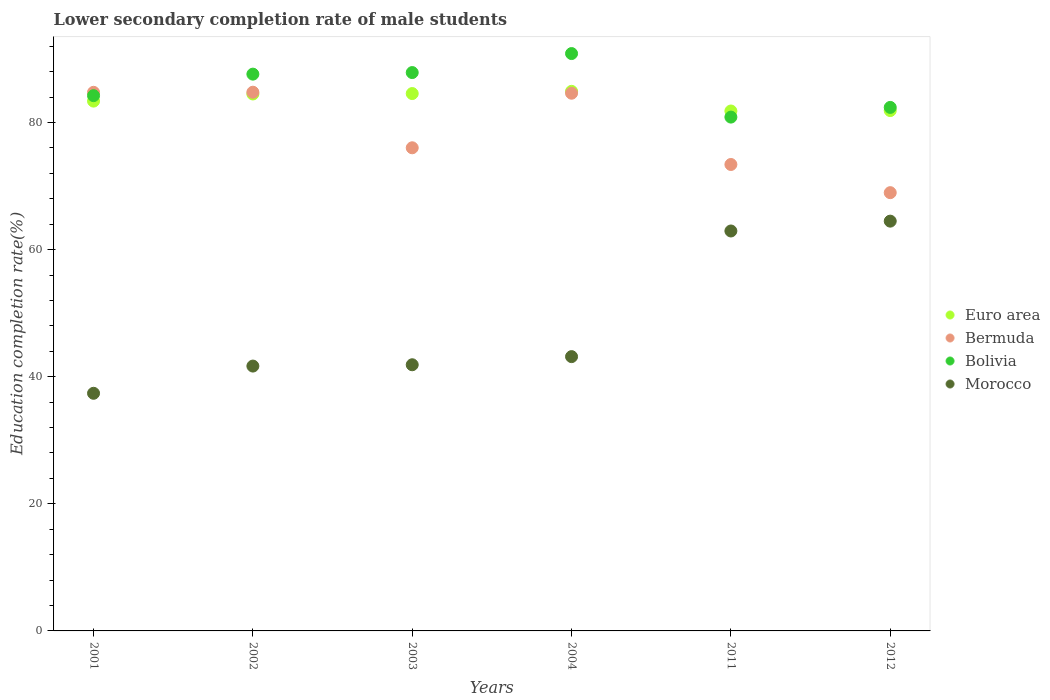What is the lower secondary completion rate of male students in Euro area in 2002?
Your answer should be very brief. 84.5. Across all years, what is the maximum lower secondary completion rate of male students in Bermuda?
Your response must be concise. 84.77. Across all years, what is the minimum lower secondary completion rate of male students in Morocco?
Offer a very short reply. 37.39. What is the total lower secondary completion rate of male students in Euro area in the graph?
Keep it short and to the point. 501.04. What is the difference between the lower secondary completion rate of male students in Euro area in 2001 and that in 2012?
Offer a terse response. 1.49. What is the difference between the lower secondary completion rate of male students in Euro area in 2004 and the lower secondary completion rate of male students in Bermuda in 2002?
Your response must be concise. 0.14. What is the average lower secondary completion rate of male students in Bolivia per year?
Make the answer very short. 85.63. In the year 2004, what is the difference between the lower secondary completion rate of male students in Morocco and lower secondary completion rate of male students in Euro area?
Provide a short and direct response. -41.74. In how many years, is the lower secondary completion rate of male students in Bermuda greater than 48 %?
Your answer should be very brief. 6. What is the ratio of the lower secondary completion rate of male students in Bermuda in 2001 to that in 2003?
Offer a very short reply. 1.11. Is the difference between the lower secondary completion rate of male students in Morocco in 2001 and 2004 greater than the difference between the lower secondary completion rate of male students in Euro area in 2001 and 2004?
Provide a succinct answer. No. What is the difference between the highest and the second highest lower secondary completion rate of male students in Bolivia?
Offer a terse response. 2.99. What is the difference between the highest and the lowest lower secondary completion rate of male students in Morocco?
Your answer should be very brief. 27.09. In how many years, is the lower secondary completion rate of male students in Bolivia greater than the average lower secondary completion rate of male students in Bolivia taken over all years?
Provide a short and direct response. 3. Is the sum of the lower secondary completion rate of male students in Euro area in 2004 and 2011 greater than the maximum lower secondary completion rate of male students in Bolivia across all years?
Your answer should be very brief. Yes. Is it the case that in every year, the sum of the lower secondary completion rate of male students in Bermuda and lower secondary completion rate of male students in Euro area  is greater than the sum of lower secondary completion rate of male students in Bolivia and lower secondary completion rate of male students in Morocco?
Ensure brevity in your answer.  No. Is it the case that in every year, the sum of the lower secondary completion rate of male students in Bolivia and lower secondary completion rate of male students in Bermuda  is greater than the lower secondary completion rate of male students in Morocco?
Make the answer very short. Yes. Does the lower secondary completion rate of male students in Bermuda monotonically increase over the years?
Keep it short and to the point. No. Is the lower secondary completion rate of male students in Morocco strictly greater than the lower secondary completion rate of male students in Bermuda over the years?
Give a very brief answer. No. Is the lower secondary completion rate of male students in Bolivia strictly less than the lower secondary completion rate of male students in Bermuda over the years?
Provide a short and direct response. No. Are the values on the major ticks of Y-axis written in scientific E-notation?
Offer a terse response. No. Does the graph contain any zero values?
Give a very brief answer. No. Does the graph contain grids?
Make the answer very short. No. How many legend labels are there?
Keep it short and to the point. 4. How are the legend labels stacked?
Your response must be concise. Vertical. What is the title of the graph?
Offer a very short reply. Lower secondary completion rate of male students. Does "Honduras" appear as one of the legend labels in the graph?
Offer a very short reply. No. What is the label or title of the X-axis?
Offer a very short reply. Years. What is the label or title of the Y-axis?
Offer a terse response. Education completion rate(%). What is the Education completion rate(%) of Euro area in 2001?
Your answer should be compact. 83.37. What is the Education completion rate(%) in Bermuda in 2001?
Provide a succinct answer. 84.76. What is the Education completion rate(%) in Bolivia in 2001?
Offer a terse response. 84.23. What is the Education completion rate(%) in Morocco in 2001?
Give a very brief answer. 37.39. What is the Education completion rate(%) in Euro area in 2002?
Make the answer very short. 84.5. What is the Education completion rate(%) of Bermuda in 2002?
Your response must be concise. 84.77. What is the Education completion rate(%) in Bolivia in 2002?
Offer a terse response. 87.62. What is the Education completion rate(%) in Morocco in 2002?
Make the answer very short. 41.68. What is the Education completion rate(%) of Euro area in 2003?
Provide a succinct answer. 84.56. What is the Education completion rate(%) of Bermuda in 2003?
Ensure brevity in your answer.  76.03. What is the Education completion rate(%) in Bolivia in 2003?
Make the answer very short. 87.86. What is the Education completion rate(%) of Morocco in 2003?
Keep it short and to the point. 41.88. What is the Education completion rate(%) of Euro area in 2004?
Make the answer very short. 84.91. What is the Education completion rate(%) of Bermuda in 2004?
Keep it short and to the point. 84.62. What is the Education completion rate(%) of Bolivia in 2004?
Offer a very short reply. 90.86. What is the Education completion rate(%) of Morocco in 2004?
Your answer should be very brief. 43.16. What is the Education completion rate(%) of Euro area in 2011?
Offer a terse response. 81.82. What is the Education completion rate(%) in Bermuda in 2011?
Provide a succinct answer. 73.4. What is the Education completion rate(%) in Bolivia in 2011?
Give a very brief answer. 80.86. What is the Education completion rate(%) in Morocco in 2011?
Your answer should be compact. 62.94. What is the Education completion rate(%) in Euro area in 2012?
Your response must be concise. 81.88. What is the Education completion rate(%) of Bermuda in 2012?
Your answer should be compact. 68.97. What is the Education completion rate(%) of Bolivia in 2012?
Your response must be concise. 82.38. What is the Education completion rate(%) in Morocco in 2012?
Offer a very short reply. 64.48. Across all years, what is the maximum Education completion rate(%) of Euro area?
Offer a terse response. 84.91. Across all years, what is the maximum Education completion rate(%) of Bermuda?
Provide a succinct answer. 84.77. Across all years, what is the maximum Education completion rate(%) in Bolivia?
Offer a terse response. 90.86. Across all years, what is the maximum Education completion rate(%) in Morocco?
Your response must be concise. 64.48. Across all years, what is the minimum Education completion rate(%) of Euro area?
Keep it short and to the point. 81.82. Across all years, what is the minimum Education completion rate(%) in Bermuda?
Your response must be concise. 68.97. Across all years, what is the minimum Education completion rate(%) in Bolivia?
Provide a succinct answer. 80.86. Across all years, what is the minimum Education completion rate(%) of Morocco?
Keep it short and to the point. 37.39. What is the total Education completion rate(%) in Euro area in the graph?
Offer a terse response. 501.04. What is the total Education completion rate(%) of Bermuda in the graph?
Make the answer very short. 472.54. What is the total Education completion rate(%) in Bolivia in the graph?
Give a very brief answer. 513.81. What is the total Education completion rate(%) in Morocco in the graph?
Offer a terse response. 291.54. What is the difference between the Education completion rate(%) in Euro area in 2001 and that in 2002?
Provide a short and direct response. -1.12. What is the difference between the Education completion rate(%) in Bermuda in 2001 and that in 2002?
Provide a short and direct response. -0.02. What is the difference between the Education completion rate(%) in Bolivia in 2001 and that in 2002?
Your answer should be compact. -3.39. What is the difference between the Education completion rate(%) of Morocco in 2001 and that in 2002?
Provide a succinct answer. -4.28. What is the difference between the Education completion rate(%) in Euro area in 2001 and that in 2003?
Give a very brief answer. -1.19. What is the difference between the Education completion rate(%) in Bermuda in 2001 and that in 2003?
Offer a terse response. 8.73. What is the difference between the Education completion rate(%) in Bolivia in 2001 and that in 2003?
Offer a terse response. -3.63. What is the difference between the Education completion rate(%) in Morocco in 2001 and that in 2003?
Give a very brief answer. -4.49. What is the difference between the Education completion rate(%) of Euro area in 2001 and that in 2004?
Give a very brief answer. -1.54. What is the difference between the Education completion rate(%) of Bermuda in 2001 and that in 2004?
Make the answer very short. 0.14. What is the difference between the Education completion rate(%) in Bolivia in 2001 and that in 2004?
Your answer should be very brief. -6.62. What is the difference between the Education completion rate(%) in Morocco in 2001 and that in 2004?
Provide a succinct answer. -5.77. What is the difference between the Education completion rate(%) of Euro area in 2001 and that in 2011?
Provide a short and direct response. 1.56. What is the difference between the Education completion rate(%) in Bermuda in 2001 and that in 2011?
Give a very brief answer. 11.36. What is the difference between the Education completion rate(%) of Bolivia in 2001 and that in 2011?
Provide a succinct answer. 3.37. What is the difference between the Education completion rate(%) in Morocco in 2001 and that in 2011?
Ensure brevity in your answer.  -25.54. What is the difference between the Education completion rate(%) in Euro area in 2001 and that in 2012?
Provide a short and direct response. 1.49. What is the difference between the Education completion rate(%) of Bermuda in 2001 and that in 2012?
Provide a succinct answer. 15.79. What is the difference between the Education completion rate(%) of Bolivia in 2001 and that in 2012?
Offer a very short reply. 1.85. What is the difference between the Education completion rate(%) in Morocco in 2001 and that in 2012?
Make the answer very short. -27.09. What is the difference between the Education completion rate(%) of Euro area in 2002 and that in 2003?
Provide a short and direct response. -0.07. What is the difference between the Education completion rate(%) in Bermuda in 2002 and that in 2003?
Offer a very short reply. 8.75. What is the difference between the Education completion rate(%) in Bolivia in 2002 and that in 2003?
Offer a terse response. -0.25. What is the difference between the Education completion rate(%) in Morocco in 2002 and that in 2003?
Your response must be concise. -0.21. What is the difference between the Education completion rate(%) in Euro area in 2002 and that in 2004?
Make the answer very short. -0.41. What is the difference between the Education completion rate(%) of Bermuda in 2002 and that in 2004?
Ensure brevity in your answer.  0.16. What is the difference between the Education completion rate(%) in Bolivia in 2002 and that in 2004?
Your response must be concise. -3.24. What is the difference between the Education completion rate(%) in Morocco in 2002 and that in 2004?
Provide a short and direct response. -1.49. What is the difference between the Education completion rate(%) in Euro area in 2002 and that in 2011?
Provide a succinct answer. 2.68. What is the difference between the Education completion rate(%) in Bermuda in 2002 and that in 2011?
Provide a short and direct response. 11.37. What is the difference between the Education completion rate(%) of Bolivia in 2002 and that in 2011?
Keep it short and to the point. 6.76. What is the difference between the Education completion rate(%) of Morocco in 2002 and that in 2011?
Your answer should be compact. -21.26. What is the difference between the Education completion rate(%) of Euro area in 2002 and that in 2012?
Make the answer very short. 2.61. What is the difference between the Education completion rate(%) of Bermuda in 2002 and that in 2012?
Give a very brief answer. 15.81. What is the difference between the Education completion rate(%) in Bolivia in 2002 and that in 2012?
Make the answer very short. 5.24. What is the difference between the Education completion rate(%) of Morocco in 2002 and that in 2012?
Keep it short and to the point. -22.81. What is the difference between the Education completion rate(%) in Euro area in 2003 and that in 2004?
Give a very brief answer. -0.35. What is the difference between the Education completion rate(%) in Bermuda in 2003 and that in 2004?
Ensure brevity in your answer.  -8.59. What is the difference between the Education completion rate(%) in Bolivia in 2003 and that in 2004?
Make the answer very short. -2.99. What is the difference between the Education completion rate(%) in Morocco in 2003 and that in 2004?
Your answer should be compact. -1.28. What is the difference between the Education completion rate(%) in Euro area in 2003 and that in 2011?
Your answer should be compact. 2.75. What is the difference between the Education completion rate(%) in Bermuda in 2003 and that in 2011?
Offer a very short reply. 2.63. What is the difference between the Education completion rate(%) of Bolivia in 2003 and that in 2011?
Provide a succinct answer. 7.01. What is the difference between the Education completion rate(%) of Morocco in 2003 and that in 2011?
Offer a very short reply. -21.05. What is the difference between the Education completion rate(%) in Euro area in 2003 and that in 2012?
Offer a terse response. 2.68. What is the difference between the Education completion rate(%) in Bermuda in 2003 and that in 2012?
Make the answer very short. 7.06. What is the difference between the Education completion rate(%) of Bolivia in 2003 and that in 2012?
Give a very brief answer. 5.48. What is the difference between the Education completion rate(%) of Morocco in 2003 and that in 2012?
Ensure brevity in your answer.  -22.6. What is the difference between the Education completion rate(%) of Euro area in 2004 and that in 2011?
Offer a very short reply. 3.09. What is the difference between the Education completion rate(%) in Bermuda in 2004 and that in 2011?
Your answer should be compact. 11.22. What is the difference between the Education completion rate(%) of Bolivia in 2004 and that in 2011?
Your response must be concise. 10. What is the difference between the Education completion rate(%) in Morocco in 2004 and that in 2011?
Make the answer very short. -19.77. What is the difference between the Education completion rate(%) in Euro area in 2004 and that in 2012?
Ensure brevity in your answer.  3.02. What is the difference between the Education completion rate(%) in Bermuda in 2004 and that in 2012?
Provide a short and direct response. 15.65. What is the difference between the Education completion rate(%) in Bolivia in 2004 and that in 2012?
Ensure brevity in your answer.  8.47. What is the difference between the Education completion rate(%) of Morocco in 2004 and that in 2012?
Keep it short and to the point. -21.32. What is the difference between the Education completion rate(%) of Euro area in 2011 and that in 2012?
Ensure brevity in your answer.  -0.07. What is the difference between the Education completion rate(%) in Bermuda in 2011 and that in 2012?
Keep it short and to the point. 4.43. What is the difference between the Education completion rate(%) in Bolivia in 2011 and that in 2012?
Provide a short and direct response. -1.52. What is the difference between the Education completion rate(%) of Morocco in 2011 and that in 2012?
Provide a succinct answer. -1.55. What is the difference between the Education completion rate(%) of Euro area in 2001 and the Education completion rate(%) of Bermuda in 2002?
Your answer should be very brief. -1.4. What is the difference between the Education completion rate(%) in Euro area in 2001 and the Education completion rate(%) in Bolivia in 2002?
Make the answer very short. -4.24. What is the difference between the Education completion rate(%) in Euro area in 2001 and the Education completion rate(%) in Morocco in 2002?
Offer a very short reply. 41.7. What is the difference between the Education completion rate(%) in Bermuda in 2001 and the Education completion rate(%) in Bolivia in 2002?
Offer a very short reply. -2.86. What is the difference between the Education completion rate(%) of Bermuda in 2001 and the Education completion rate(%) of Morocco in 2002?
Your answer should be very brief. 43.08. What is the difference between the Education completion rate(%) of Bolivia in 2001 and the Education completion rate(%) of Morocco in 2002?
Provide a succinct answer. 42.55. What is the difference between the Education completion rate(%) of Euro area in 2001 and the Education completion rate(%) of Bermuda in 2003?
Ensure brevity in your answer.  7.35. What is the difference between the Education completion rate(%) of Euro area in 2001 and the Education completion rate(%) of Bolivia in 2003?
Provide a short and direct response. -4.49. What is the difference between the Education completion rate(%) in Euro area in 2001 and the Education completion rate(%) in Morocco in 2003?
Keep it short and to the point. 41.49. What is the difference between the Education completion rate(%) in Bermuda in 2001 and the Education completion rate(%) in Bolivia in 2003?
Your answer should be very brief. -3.11. What is the difference between the Education completion rate(%) of Bermuda in 2001 and the Education completion rate(%) of Morocco in 2003?
Offer a terse response. 42.87. What is the difference between the Education completion rate(%) of Bolivia in 2001 and the Education completion rate(%) of Morocco in 2003?
Provide a succinct answer. 42.35. What is the difference between the Education completion rate(%) in Euro area in 2001 and the Education completion rate(%) in Bermuda in 2004?
Make the answer very short. -1.24. What is the difference between the Education completion rate(%) of Euro area in 2001 and the Education completion rate(%) of Bolivia in 2004?
Offer a very short reply. -7.48. What is the difference between the Education completion rate(%) of Euro area in 2001 and the Education completion rate(%) of Morocco in 2004?
Provide a succinct answer. 40.21. What is the difference between the Education completion rate(%) of Bermuda in 2001 and the Education completion rate(%) of Bolivia in 2004?
Offer a terse response. -6.1. What is the difference between the Education completion rate(%) of Bermuda in 2001 and the Education completion rate(%) of Morocco in 2004?
Ensure brevity in your answer.  41.59. What is the difference between the Education completion rate(%) in Bolivia in 2001 and the Education completion rate(%) in Morocco in 2004?
Provide a succinct answer. 41.07. What is the difference between the Education completion rate(%) in Euro area in 2001 and the Education completion rate(%) in Bermuda in 2011?
Ensure brevity in your answer.  9.97. What is the difference between the Education completion rate(%) in Euro area in 2001 and the Education completion rate(%) in Bolivia in 2011?
Your response must be concise. 2.52. What is the difference between the Education completion rate(%) in Euro area in 2001 and the Education completion rate(%) in Morocco in 2011?
Give a very brief answer. 20.44. What is the difference between the Education completion rate(%) in Bermuda in 2001 and the Education completion rate(%) in Bolivia in 2011?
Your response must be concise. 3.9. What is the difference between the Education completion rate(%) in Bermuda in 2001 and the Education completion rate(%) in Morocco in 2011?
Offer a very short reply. 21.82. What is the difference between the Education completion rate(%) of Bolivia in 2001 and the Education completion rate(%) of Morocco in 2011?
Provide a succinct answer. 21.3. What is the difference between the Education completion rate(%) in Euro area in 2001 and the Education completion rate(%) in Bermuda in 2012?
Provide a short and direct response. 14.41. What is the difference between the Education completion rate(%) of Euro area in 2001 and the Education completion rate(%) of Bolivia in 2012?
Your response must be concise. 0.99. What is the difference between the Education completion rate(%) in Euro area in 2001 and the Education completion rate(%) in Morocco in 2012?
Give a very brief answer. 18.89. What is the difference between the Education completion rate(%) of Bermuda in 2001 and the Education completion rate(%) of Bolivia in 2012?
Your answer should be compact. 2.38. What is the difference between the Education completion rate(%) of Bermuda in 2001 and the Education completion rate(%) of Morocco in 2012?
Offer a very short reply. 20.27. What is the difference between the Education completion rate(%) in Bolivia in 2001 and the Education completion rate(%) in Morocco in 2012?
Provide a succinct answer. 19.75. What is the difference between the Education completion rate(%) in Euro area in 2002 and the Education completion rate(%) in Bermuda in 2003?
Your response must be concise. 8.47. What is the difference between the Education completion rate(%) of Euro area in 2002 and the Education completion rate(%) of Bolivia in 2003?
Your answer should be compact. -3.37. What is the difference between the Education completion rate(%) of Euro area in 2002 and the Education completion rate(%) of Morocco in 2003?
Your response must be concise. 42.61. What is the difference between the Education completion rate(%) in Bermuda in 2002 and the Education completion rate(%) in Bolivia in 2003?
Your answer should be very brief. -3.09. What is the difference between the Education completion rate(%) in Bermuda in 2002 and the Education completion rate(%) in Morocco in 2003?
Your answer should be compact. 42.89. What is the difference between the Education completion rate(%) in Bolivia in 2002 and the Education completion rate(%) in Morocco in 2003?
Give a very brief answer. 45.73. What is the difference between the Education completion rate(%) in Euro area in 2002 and the Education completion rate(%) in Bermuda in 2004?
Offer a very short reply. -0.12. What is the difference between the Education completion rate(%) in Euro area in 2002 and the Education completion rate(%) in Bolivia in 2004?
Provide a short and direct response. -6.36. What is the difference between the Education completion rate(%) in Euro area in 2002 and the Education completion rate(%) in Morocco in 2004?
Your answer should be very brief. 41.33. What is the difference between the Education completion rate(%) in Bermuda in 2002 and the Education completion rate(%) in Bolivia in 2004?
Your response must be concise. -6.08. What is the difference between the Education completion rate(%) in Bermuda in 2002 and the Education completion rate(%) in Morocco in 2004?
Offer a terse response. 41.61. What is the difference between the Education completion rate(%) in Bolivia in 2002 and the Education completion rate(%) in Morocco in 2004?
Provide a short and direct response. 44.45. What is the difference between the Education completion rate(%) in Euro area in 2002 and the Education completion rate(%) in Bermuda in 2011?
Keep it short and to the point. 11.1. What is the difference between the Education completion rate(%) of Euro area in 2002 and the Education completion rate(%) of Bolivia in 2011?
Make the answer very short. 3.64. What is the difference between the Education completion rate(%) in Euro area in 2002 and the Education completion rate(%) in Morocco in 2011?
Provide a short and direct response. 21.56. What is the difference between the Education completion rate(%) in Bermuda in 2002 and the Education completion rate(%) in Bolivia in 2011?
Give a very brief answer. 3.92. What is the difference between the Education completion rate(%) in Bermuda in 2002 and the Education completion rate(%) in Morocco in 2011?
Your answer should be very brief. 21.84. What is the difference between the Education completion rate(%) of Bolivia in 2002 and the Education completion rate(%) of Morocco in 2011?
Provide a short and direct response. 24.68. What is the difference between the Education completion rate(%) in Euro area in 2002 and the Education completion rate(%) in Bermuda in 2012?
Make the answer very short. 15.53. What is the difference between the Education completion rate(%) in Euro area in 2002 and the Education completion rate(%) in Bolivia in 2012?
Make the answer very short. 2.11. What is the difference between the Education completion rate(%) in Euro area in 2002 and the Education completion rate(%) in Morocco in 2012?
Your answer should be compact. 20.01. What is the difference between the Education completion rate(%) in Bermuda in 2002 and the Education completion rate(%) in Bolivia in 2012?
Your response must be concise. 2.39. What is the difference between the Education completion rate(%) in Bermuda in 2002 and the Education completion rate(%) in Morocco in 2012?
Ensure brevity in your answer.  20.29. What is the difference between the Education completion rate(%) of Bolivia in 2002 and the Education completion rate(%) of Morocco in 2012?
Ensure brevity in your answer.  23.13. What is the difference between the Education completion rate(%) of Euro area in 2003 and the Education completion rate(%) of Bermuda in 2004?
Your response must be concise. -0.05. What is the difference between the Education completion rate(%) in Euro area in 2003 and the Education completion rate(%) in Bolivia in 2004?
Make the answer very short. -6.29. What is the difference between the Education completion rate(%) of Euro area in 2003 and the Education completion rate(%) of Morocco in 2004?
Offer a terse response. 41.4. What is the difference between the Education completion rate(%) in Bermuda in 2003 and the Education completion rate(%) in Bolivia in 2004?
Provide a short and direct response. -14.83. What is the difference between the Education completion rate(%) in Bermuda in 2003 and the Education completion rate(%) in Morocco in 2004?
Give a very brief answer. 32.86. What is the difference between the Education completion rate(%) of Bolivia in 2003 and the Education completion rate(%) of Morocco in 2004?
Keep it short and to the point. 44.7. What is the difference between the Education completion rate(%) in Euro area in 2003 and the Education completion rate(%) in Bermuda in 2011?
Offer a terse response. 11.16. What is the difference between the Education completion rate(%) of Euro area in 2003 and the Education completion rate(%) of Bolivia in 2011?
Make the answer very short. 3.71. What is the difference between the Education completion rate(%) in Euro area in 2003 and the Education completion rate(%) in Morocco in 2011?
Provide a succinct answer. 21.63. What is the difference between the Education completion rate(%) of Bermuda in 2003 and the Education completion rate(%) of Bolivia in 2011?
Offer a very short reply. -4.83. What is the difference between the Education completion rate(%) in Bermuda in 2003 and the Education completion rate(%) in Morocco in 2011?
Give a very brief answer. 13.09. What is the difference between the Education completion rate(%) of Bolivia in 2003 and the Education completion rate(%) of Morocco in 2011?
Offer a very short reply. 24.93. What is the difference between the Education completion rate(%) in Euro area in 2003 and the Education completion rate(%) in Bermuda in 2012?
Ensure brevity in your answer.  15.6. What is the difference between the Education completion rate(%) of Euro area in 2003 and the Education completion rate(%) of Bolivia in 2012?
Offer a terse response. 2.18. What is the difference between the Education completion rate(%) of Euro area in 2003 and the Education completion rate(%) of Morocco in 2012?
Your response must be concise. 20.08. What is the difference between the Education completion rate(%) in Bermuda in 2003 and the Education completion rate(%) in Bolivia in 2012?
Keep it short and to the point. -6.35. What is the difference between the Education completion rate(%) of Bermuda in 2003 and the Education completion rate(%) of Morocco in 2012?
Offer a very short reply. 11.54. What is the difference between the Education completion rate(%) in Bolivia in 2003 and the Education completion rate(%) in Morocco in 2012?
Offer a terse response. 23.38. What is the difference between the Education completion rate(%) of Euro area in 2004 and the Education completion rate(%) of Bermuda in 2011?
Provide a succinct answer. 11.51. What is the difference between the Education completion rate(%) in Euro area in 2004 and the Education completion rate(%) in Bolivia in 2011?
Offer a very short reply. 4.05. What is the difference between the Education completion rate(%) of Euro area in 2004 and the Education completion rate(%) of Morocco in 2011?
Offer a very short reply. 21.97. What is the difference between the Education completion rate(%) in Bermuda in 2004 and the Education completion rate(%) in Bolivia in 2011?
Your response must be concise. 3.76. What is the difference between the Education completion rate(%) of Bermuda in 2004 and the Education completion rate(%) of Morocco in 2011?
Give a very brief answer. 21.68. What is the difference between the Education completion rate(%) in Bolivia in 2004 and the Education completion rate(%) in Morocco in 2011?
Make the answer very short. 27.92. What is the difference between the Education completion rate(%) of Euro area in 2004 and the Education completion rate(%) of Bermuda in 2012?
Make the answer very short. 15.94. What is the difference between the Education completion rate(%) of Euro area in 2004 and the Education completion rate(%) of Bolivia in 2012?
Your response must be concise. 2.53. What is the difference between the Education completion rate(%) in Euro area in 2004 and the Education completion rate(%) in Morocco in 2012?
Your response must be concise. 20.42. What is the difference between the Education completion rate(%) of Bermuda in 2004 and the Education completion rate(%) of Bolivia in 2012?
Keep it short and to the point. 2.23. What is the difference between the Education completion rate(%) in Bermuda in 2004 and the Education completion rate(%) in Morocco in 2012?
Offer a very short reply. 20.13. What is the difference between the Education completion rate(%) of Bolivia in 2004 and the Education completion rate(%) of Morocco in 2012?
Your answer should be very brief. 26.37. What is the difference between the Education completion rate(%) in Euro area in 2011 and the Education completion rate(%) in Bermuda in 2012?
Your response must be concise. 12.85. What is the difference between the Education completion rate(%) of Euro area in 2011 and the Education completion rate(%) of Bolivia in 2012?
Offer a terse response. -0.56. What is the difference between the Education completion rate(%) in Euro area in 2011 and the Education completion rate(%) in Morocco in 2012?
Give a very brief answer. 17.33. What is the difference between the Education completion rate(%) in Bermuda in 2011 and the Education completion rate(%) in Bolivia in 2012?
Offer a very short reply. -8.98. What is the difference between the Education completion rate(%) of Bermuda in 2011 and the Education completion rate(%) of Morocco in 2012?
Keep it short and to the point. 8.91. What is the difference between the Education completion rate(%) of Bolivia in 2011 and the Education completion rate(%) of Morocco in 2012?
Your response must be concise. 16.37. What is the average Education completion rate(%) in Euro area per year?
Your answer should be compact. 83.51. What is the average Education completion rate(%) in Bermuda per year?
Ensure brevity in your answer.  78.76. What is the average Education completion rate(%) of Bolivia per year?
Your response must be concise. 85.63. What is the average Education completion rate(%) in Morocco per year?
Offer a very short reply. 48.59. In the year 2001, what is the difference between the Education completion rate(%) in Euro area and Education completion rate(%) in Bermuda?
Offer a very short reply. -1.39. In the year 2001, what is the difference between the Education completion rate(%) of Euro area and Education completion rate(%) of Bolivia?
Give a very brief answer. -0.86. In the year 2001, what is the difference between the Education completion rate(%) of Euro area and Education completion rate(%) of Morocco?
Provide a succinct answer. 45.98. In the year 2001, what is the difference between the Education completion rate(%) of Bermuda and Education completion rate(%) of Bolivia?
Give a very brief answer. 0.53. In the year 2001, what is the difference between the Education completion rate(%) of Bermuda and Education completion rate(%) of Morocco?
Provide a succinct answer. 47.36. In the year 2001, what is the difference between the Education completion rate(%) of Bolivia and Education completion rate(%) of Morocco?
Ensure brevity in your answer.  46.84. In the year 2002, what is the difference between the Education completion rate(%) in Euro area and Education completion rate(%) in Bermuda?
Your answer should be compact. -0.28. In the year 2002, what is the difference between the Education completion rate(%) of Euro area and Education completion rate(%) of Bolivia?
Make the answer very short. -3.12. In the year 2002, what is the difference between the Education completion rate(%) in Euro area and Education completion rate(%) in Morocco?
Ensure brevity in your answer.  42.82. In the year 2002, what is the difference between the Education completion rate(%) in Bermuda and Education completion rate(%) in Bolivia?
Keep it short and to the point. -2.84. In the year 2002, what is the difference between the Education completion rate(%) of Bermuda and Education completion rate(%) of Morocco?
Your answer should be compact. 43.1. In the year 2002, what is the difference between the Education completion rate(%) in Bolivia and Education completion rate(%) in Morocco?
Provide a short and direct response. 45.94. In the year 2003, what is the difference between the Education completion rate(%) of Euro area and Education completion rate(%) of Bermuda?
Give a very brief answer. 8.53. In the year 2003, what is the difference between the Education completion rate(%) in Euro area and Education completion rate(%) in Bolivia?
Give a very brief answer. -3.3. In the year 2003, what is the difference between the Education completion rate(%) in Euro area and Education completion rate(%) in Morocco?
Your answer should be very brief. 42.68. In the year 2003, what is the difference between the Education completion rate(%) in Bermuda and Education completion rate(%) in Bolivia?
Keep it short and to the point. -11.84. In the year 2003, what is the difference between the Education completion rate(%) of Bermuda and Education completion rate(%) of Morocco?
Your answer should be compact. 34.14. In the year 2003, what is the difference between the Education completion rate(%) in Bolivia and Education completion rate(%) in Morocco?
Give a very brief answer. 45.98. In the year 2004, what is the difference between the Education completion rate(%) of Euro area and Education completion rate(%) of Bermuda?
Provide a succinct answer. 0.29. In the year 2004, what is the difference between the Education completion rate(%) in Euro area and Education completion rate(%) in Bolivia?
Ensure brevity in your answer.  -5.95. In the year 2004, what is the difference between the Education completion rate(%) of Euro area and Education completion rate(%) of Morocco?
Offer a very short reply. 41.74. In the year 2004, what is the difference between the Education completion rate(%) in Bermuda and Education completion rate(%) in Bolivia?
Your answer should be compact. -6.24. In the year 2004, what is the difference between the Education completion rate(%) of Bermuda and Education completion rate(%) of Morocco?
Offer a very short reply. 41.45. In the year 2004, what is the difference between the Education completion rate(%) of Bolivia and Education completion rate(%) of Morocco?
Provide a short and direct response. 47.69. In the year 2011, what is the difference between the Education completion rate(%) of Euro area and Education completion rate(%) of Bermuda?
Ensure brevity in your answer.  8.42. In the year 2011, what is the difference between the Education completion rate(%) in Euro area and Education completion rate(%) in Bolivia?
Offer a very short reply. 0.96. In the year 2011, what is the difference between the Education completion rate(%) in Euro area and Education completion rate(%) in Morocco?
Your answer should be compact. 18.88. In the year 2011, what is the difference between the Education completion rate(%) in Bermuda and Education completion rate(%) in Bolivia?
Offer a terse response. -7.46. In the year 2011, what is the difference between the Education completion rate(%) in Bermuda and Education completion rate(%) in Morocco?
Your answer should be compact. 10.46. In the year 2011, what is the difference between the Education completion rate(%) in Bolivia and Education completion rate(%) in Morocco?
Provide a succinct answer. 17.92. In the year 2012, what is the difference between the Education completion rate(%) in Euro area and Education completion rate(%) in Bermuda?
Provide a succinct answer. 12.92. In the year 2012, what is the difference between the Education completion rate(%) in Euro area and Education completion rate(%) in Bolivia?
Ensure brevity in your answer.  -0.5. In the year 2012, what is the difference between the Education completion rate(%) in Euro area and Education completion rate(%) in Morocco?
Give a very brief answer. 17.4. In the year 2012, what is the difference between the Education completion rate(%) of Bermuda and Education completion rate(%) of Bolivia?
Your answer should be very brief. -13.42. In the year 2012, what is the difference between the Education completion rate(%) of Bermuda and Education completion rate(%) of Morocco?
Your answer should be compact. 4.48. In the year 2012, what is the difference between the Education completion rate(%) in Bolivia and Education completion rate(%) in Morocco?
Keep it short and to the point. 17.9. What is the ratio of the Education completion rate(%) in Euro area in 2001 to that in 2002?
Offer a very short reply. 0.99. What is the ratio of the Education completion rate(%) of Bermuda in 2001 to that in 2002?
Provide a succinct answer. 1. What is the ratio of the Education completion rate(%) in Bolivia in 2001 to that in 2002?
Your answer should be very brief. 0.96. What is the ratio of the Education completion rate(%) of Morocco in 2001 to that in 2002?
Offer a very short reply. 0.9. What is the ratio of the Education completion rate(%) of Euro area in 2001 to that in 2003?
Provide a short and direct response. 0.99. What is the ratio of the Education completion rate(%) of Bermuda in 2001 to that in 2003?
Make the answer very short. 1.11. What is the ratio of the Education completion rate(%) in Bolivia in 2001 to that in 2003?
Your answer should be very brief. 0.96. What is the ratio of the Education completion rate(%) in Morocco in 2001 to that in 2003?
Make the answer very short. 0.89. What is the ratio of the Education completion rate(%) of Euro area in 2001 to that in 2004?
Keep it short and to the point. 0.98. What is the ratio of the Education completion rate(%) in Bermuda in 2001 to that in 2004?
Offer a very short reply. 1. What is the ratio of the Education completion rate(%) in Bolivia in 2001 to that in 2004?
Your answer should be compact. 0.93. What is the ratio of the Education completion rate(%) of Morocco in 2001 to that in 2004?
Your answer should be very brief. 0.87. What is the ratio of the Education completion rate(%) in Bermuda in 2001 to that in 2011?
Provide a short and direct response. 1.15. What is the ratio of the Education completion rate(%) of Bolivia in 2001 to that in 2011?
Your answer should be compact. 1.04. What is the ratio of the Education completion rate(%) of Morocco in 2001 to that in 2011?
Ensure brevity in your answer.  0.59. What is the ratio of the Education completion rate(%) in Euro area in 2001 to that in 2012?
Provide a succinct answer. 1.02. What is the ratio of the Education completion rate(%) in Bermuda in 2001 to that in 2012?
Provide a succinct answer. 1.23. What is the ratio of the Education completion rate(%) in Bolivia in 2001 to that in 2012?
Give a very brief answer. 1.02. What is the ratio of the Education completion rate(%) of Morocco in 2001 to that in 2012?
Your answer should be very brief. 0.58. What is the ratio of the Education completion rate(%) of Bermuda in 2002 to that in 2003?
Offer a very short reply. 1.11. What is the ratio of the Education completion rate(%) of Bolivia in 2002 to that in 2003?
Your answer should be compact. 1. What is the ratio of the Education completion rate(%) of Euro area in 2002 to that in 2004?
Offer a very short reply. 1. What is the ratio of the Education completion rate(%) of Bolivia in 2002 to that in 2004?
Keep it short and to the point. 0.96. What is the ratio of the Education completion rate(%) of Morocco in 2002 to that in 2004?
Provide a short and direct response. 0.97. What is the ratio of the Education completion rate(%) of Euro area in 2002 to that in 2011?
Your answer should be very brief. 1.03. What is the ratio of the Education completion rate(%) of Bermuda in 2002 to that in 2011?
Your response must be concise. 1.16. What is the ratio of the Education completion rate(%) in Bolivia in 2002 to that in 2011?
Keep it short and to the point. 1.08. What is the ratio of the Education completion rate(%) of Morocco in 2002 to that in 2011?
Offer a very short reply. 0.66. What is the ratio of the Education completion rate(%) of Euro area in 2002 to that in 2012?
Your answer should be compact. 1.03. What is the ratio of the Education completion rate(%) of Bermuda in 2002 to that in 2012?
Your answer should be very brief. 1.23. What is the ratio of the Education completion rate(%) of Bolivia in 2002 to that in 2012?
Keep it short and to the point. 1.06. What is the ratio of the Education completion rate(%) in Morocco in 2002 to that in 2012?
Provide a succinct answer. 0.65. What is the ratio of the Education completion rate(%) in Bermuda in 2003 to that in 2004?
Keep it short and to the point. 0.9. What is the ratio of the Education completion rate(%) of Bolivia in 2003 to that in 2004?
Your answer should be very brief. 0.97. What is the ratio of the Education completion rate(%) of Morocco in 2003 to that in 2004?
Offer a very short reply. 0.97. What is the ratio of the Education completion rate(%) in Euro area in 2003 to that in 2011?
Provide a short and direct response. 1.03. What is the ratio of the Education completion rate(%) of Bermuda in 2003 to that in 2011?
Provide a succinct answer. 1.04. What is the ratio of the Education completion rate(%) of Bolivia in 2003 to that in 2011?
Provide a succinct answer. 1.09. What is the ratio of the Education completion rate(%) of Morocco in 2003 to that in 2011?
Keep it short and to the point. 0.67. What is the ratio of the Education completion rate(%) of Euro area in 2003 to that in 2012?
Your answer should be compact. 1.03. What is the ratio of the Education completion rate(%) in Bermuda in 2003 to that in 2012?
Provide a short and direct response. 1.1. What is the ratio of the Education completion rate(%) of Bolivia in 2003 to that in 2012?
Your response must be concise. 1.07. What is the ratio of the Education completion rate(%) in Morocco in 2003 to that in 2012?
Give a very brief answer. 0.65. What is the ratio of the Education completion rate(%) in Euro area in 2004 to that in 2011?
Keep it short and to the point. 1.04. What is the ratio of the Education completion rate(%) in Bermuda in 2004 to that in 2011?
Offer a terse response. 1.15. What is the ratio of the Education completion rate(%) of Bolivia in 2004 to that in 2011?
Ensure brevity in your answer.  1.12. What is the ratio of the Education completion rate(%) of Morocco in 2004 to that in 2011?
Provide a succinct answer. 0.69. What is the ratio of the Education completion rate(%) of Euro area in 2004 to that in 2012?
Your answer should be compact. 1.04. What is the ratio of the Education completion rate(%) of Bermuda in 2004 to that in 2012?
Provide a succinct answer. 1.23. What is the ratio of the Education completion rate(%) in Bolivia in 2004 to that in 2012?
Your answer should be compact. 1.1. What is the ratio of the Education completion rate(%) of Morocco in 2004 to that in 2012?
Provide a short and direct response. 0.67. What is the ratio of the Education completion rate(%) in Euro area in 2011 to that in 2012?
Your answer should be compact. 1. What is the ratio of the Education completion rate(%) of Bermuda in 2011 to that in 2012?
Keep it short and to the point. 1.06. What is the ratio of the Education completion rate(%) in Bolivia in 2011 to that in 2012?
Offer a very short reply. 0.98. What is the difference between the highest and the second highest Education completion rate(%) in Euro area?
Provide a succinct answer. 0.35. What is the difference between the highest and the second highest Education completion rate(%) in Bermuda?
Your answer should be compact. 0.02. What is the difference between the highest and the second highest Education completion rate(%) of Bolivia?
Give a very brief answer. 2.99. What is the difference between the highest and the second highest Education completion rate(%) of Morocco?
Your answer should be very brief. 1.55. What is the difference between the highest and the lowest Education completion rate(%) in Euro area?
Give a very brief answer. 3.09. What is the difference between the highest and the lowest Education completion rate(%) of Bermuda?
Your answer should be very brief. 15.81. What is the difference between the highest and the lowest Education completion rate(%) of Bolivia?
Give a very brief answer. 10. What is the difference between the highest and the lowest Education completion rate(%) of Morocco?
Provide a short and direct response. 27.09. 